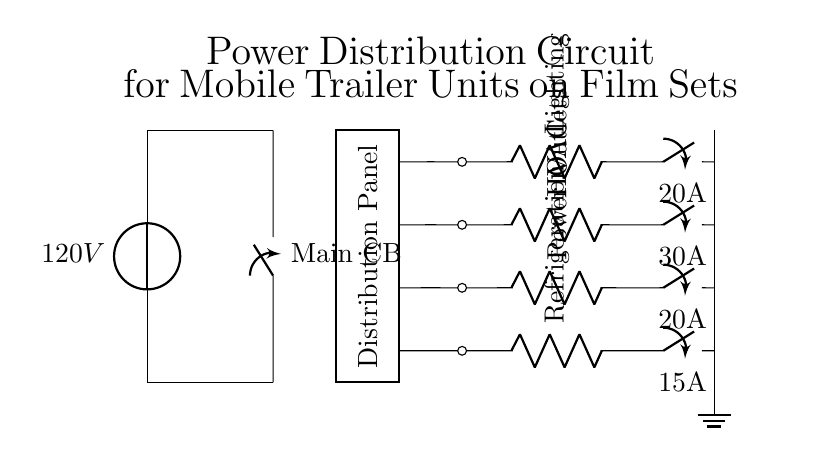What is the main voltage level of this circuit? The main voltage is shown to be 120V, which is indicated near the voltage source in the diagram.
Answer: 120V What is the purpose of the main circuit breaker? The main circuit breaker is used to control and protect the entire electrical circuit, which is depicted as a closing switch between the power supply lines.
Answer: Protect main circuit How many circuits are connected to the distribution panel? Four circuits are visible in the diagram, each connected to the distribution panel with different load designs.
Answer: Four What is the maximum current rating for the HVAC circuit? The HVAC circuit has a current rating of 30A, which is labeled next to the closing switch in that section of the circuit.
Answer: 30A Which component provides power for lighting in the circuit? The lighting component is represented by a resistor labeled "Lighting," indicating its function of supplying power for lighting purposes.
Answer: Lighting How does the power outlet circuit compare to the refrigeration circuit in terms of current capacity? The power outlet circuit has a rating of 20A while the refrigeration circuit has a rating of 15A, meaning the power outlet can handle more current than the refrigeration.
Answer: 20A vs 15A What is the function of the ground in this circuit? The ground serves to provide a safe pathway for electrical current to prevent shock and equipment damage; it connects to the ground node at the bottom of the circuit diagram.
Answer: Safety 